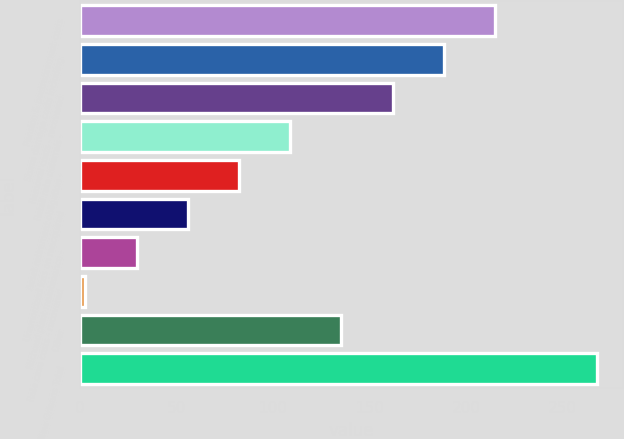<chart> <loc_0><loc_0><loc_500><loc_500><bar_chart><fcel>Pension & postretirement costs<fcel>Storm damage costs including<fcel>Removal costs - recovered<fcel>Retail rate deferrals -<fcel>Asset retirement obligation -<fcel>Unamortized loss on reacquired<fcel>Michoud plant maintenance -<fcel>Rate case costs - recovered<fcel>Other<fcel>Entergy New Orleans Total<nl><fcel>215.08<fcel>188.57<fcel>162.06<fcel>109.04<fcel>82.53<fcel>56.02<fcel>29.51<fcel>3<fcel>135.55<fcel>268.1<nl></chart> 